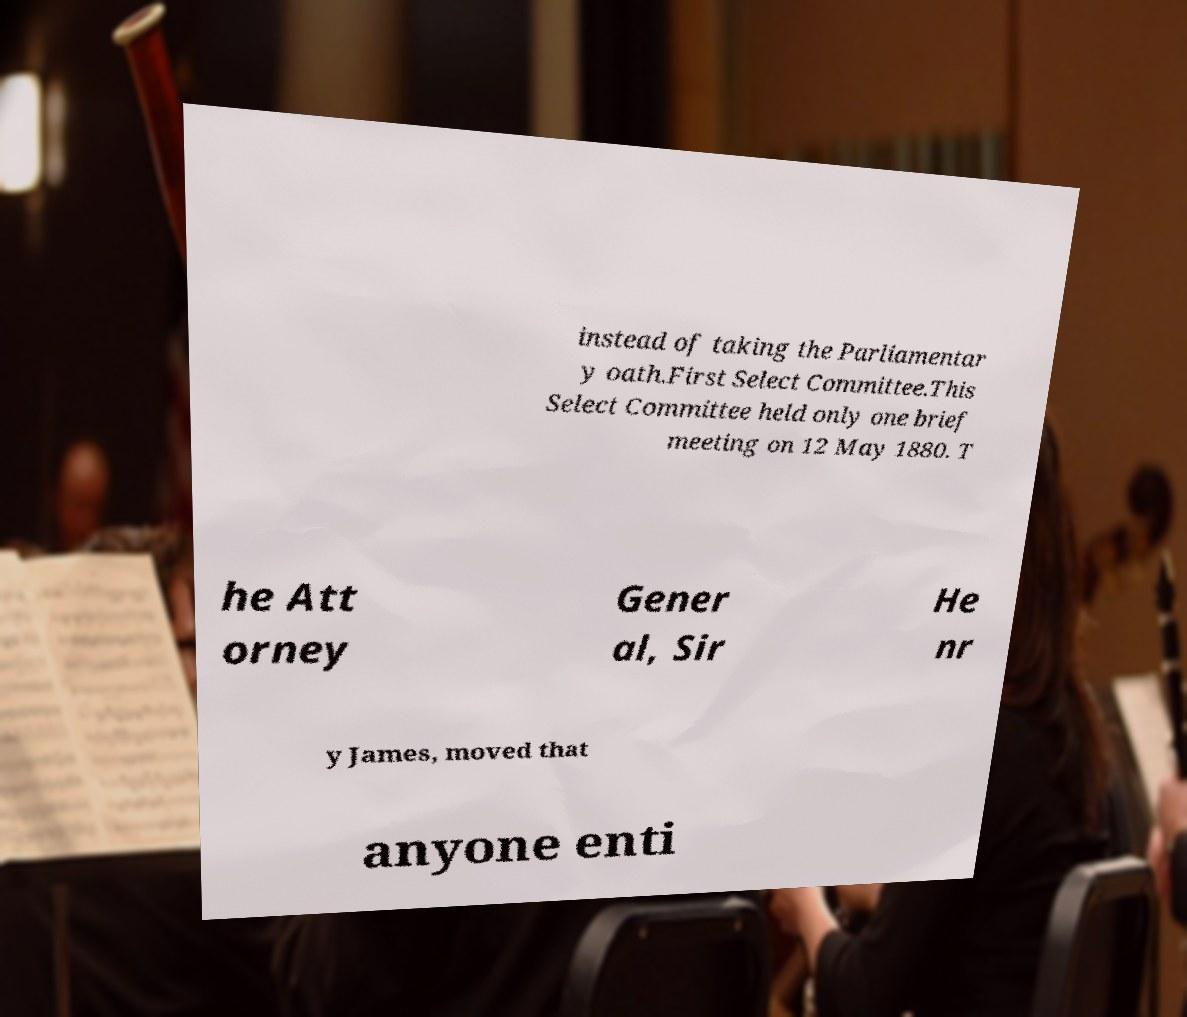Could you assist in decoding the text presented in this image and type it out clearly? instead of taking the Parliamentar y oath.First Select Committee.This Select Committee held only one brief meeting on 12 May 1880. T he Att orney Gener al, Sir He nr y James, moved that anyone enti 